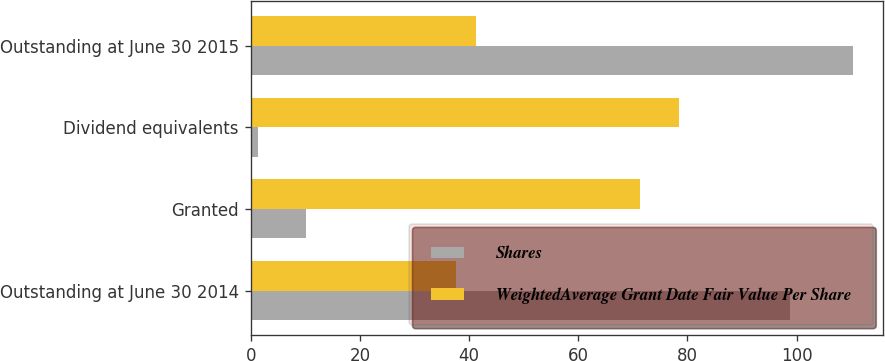Convert chart to OTSL. <chart><loc_0><loc_0><loc_500><loc_500><stacked_bar_chart><ecel><fcel>Outstanding at June 30 2014<fcel>Granted<fcel>Dividend equivalents<fcel>Outstanding at June 30 2015<nl><fcel>Shares<fcel>98.8<fcel>10.2<fcel>1.3<fcel>110.3<nl><fcel>WeightedAverage Grant Date Fair Value Per Share<fcel>37.67<fcel>71.33<fcel>78.44<fcel>41.24<nl></chart> 